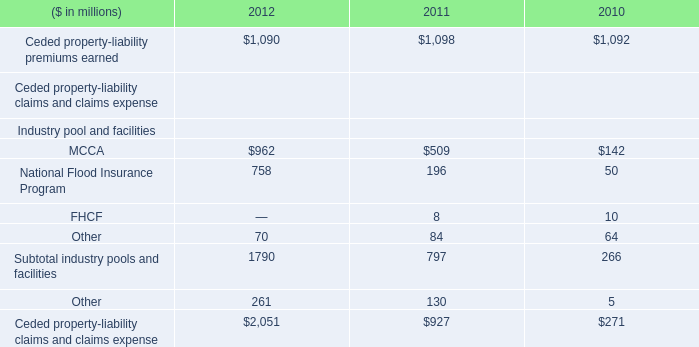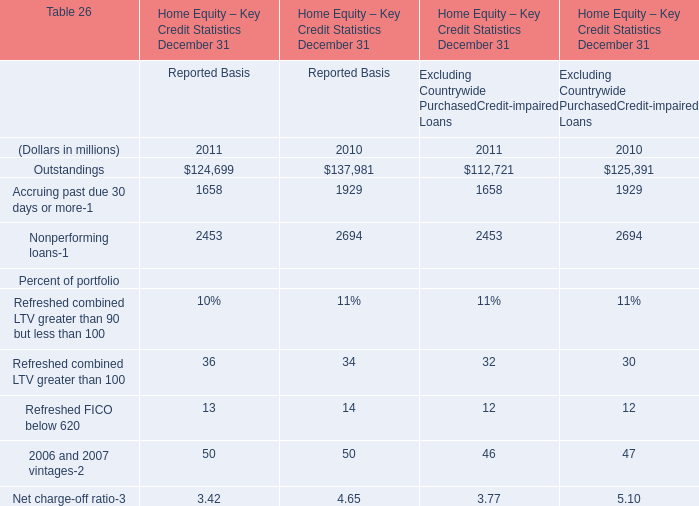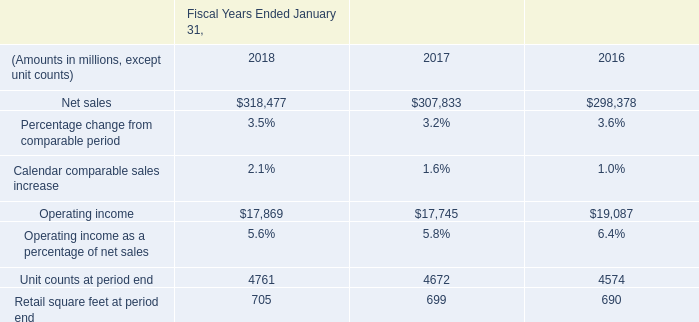What is the growing rate of Refreshed combined LTV greater than 100 in the years with the least Reported Basis? 
Computations: ((36 - 34) / 36)
Answer: 0.05556. 